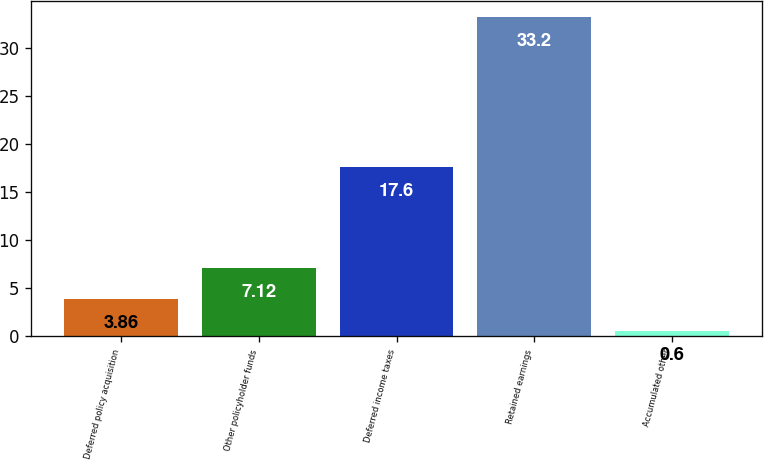<chart> <loc_0><loc_0><loc_500><loc_500><bar_chart><fcel>Deferred policy acquisition<fcel>Other policyholder funds<fcel>Deferred income taxes<fcel>Retained earnings<fcel>Accumulated other<nl><fcel>3.86<fcel>7.12<fcel>17.6<fcel>33.2<fcel>0.6<nl></chart> 